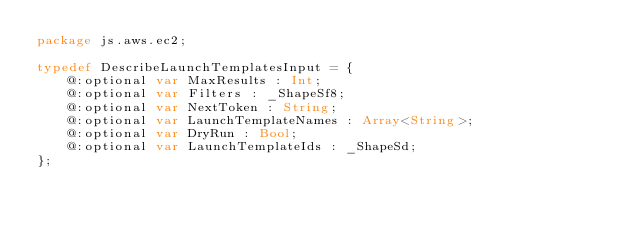<code> <loc_0><loc_0><loc_500><loc_500><_Haxe_>package js.aws.ec2;

typedef DescribeLaunchTemplatesInput = {
    @:optional var MaxResults : Int;
    @:optional var Filters : _ShapeSf8;
    @:optional var NextToken : String;
    @:optional var LaunchTemplateNames : Array<String>;
    @:optional var DryRun : Bool;
    @:optional var LaunchTemplateIds : _ShapeSd;
};
</code> 